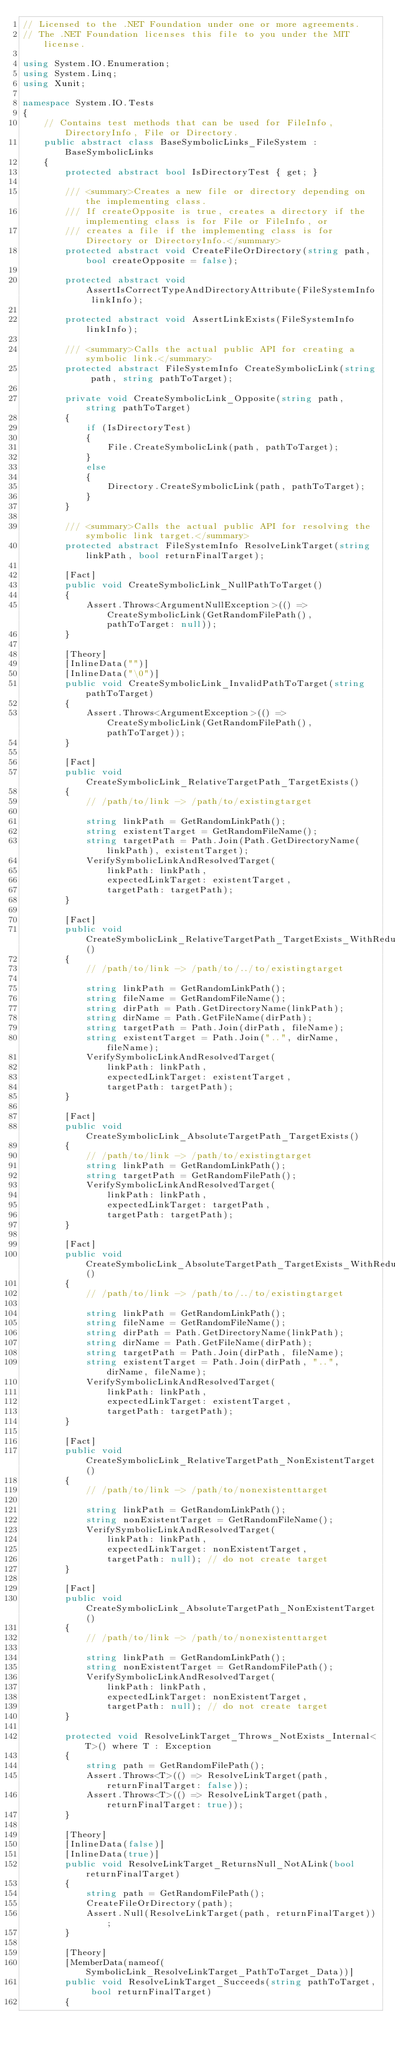Convert code to text. <code><loc_0><loc_0><loc_500><loc_500><_C#_>// Licensed to the .NET Foundation under one or more agreements.
// The .NET Foundation licenses this file to you under the MIT license.

using System.IO.Enumeration;
using System.Linq;
using Xunit;

namespace System.IO.Tests
{
    // Contains test methods that can be used for FileInfo, DirectoryInfo, File or Directory.
    public abstract class BaseSymbolicLinks_FileSystem : BaseSymbolicLinks
    {
        protected abstract bool IsDirectoryTest { get; }

        /// <summary>Creates a new file or directory depending on the implementing class.
        /// If createOpposite is true, creates a directory if the implementing class is for File or FileInfo, or
        /// creates a file if the implementing class is for Directory or DirectoryInfo.</summary>
        protected abstract void CreateFileOrDirectory(string path, bool createOpposite = false);

        protected abstract void AssertIsCorrectTypeAndDirectoryAttribute(FileSystemInfo linkInfo);

        protected abstract void AssertLinkExists(FileSystemInfo linkInfo);

        /// <summary>Calls the actual public API for creating a symbolic link.</summary>
        protected abstract FileSystemInfo CreateSymbolicLink(string path, string pathToTarget);

        private void CreateSymbolicLink_Opposite(string path, string pathToTarget)
        {
            if (IsDirectoryTest)
            {
                File.CreateSymbolicLink(path, pathToTarget);
            }
            else
            {
                Directory.CreateSymbolicLink(path, pathToTarget);
            }
        }

        /// <summary>Calls the actual public API for resolving the symbolic link target.</summary>
        protected abstract FileSystemInfo ResolveLinkTarget(string linkPath, bool returnFinalTarget);

        [Fact]
        public void CreateSymbolicLink_NullPathToTarget()
        {
            Assert.Throws<ArgumentNullException>(() => CreateSymbolicLink(GetRandomFilePath(), pathToTarget: null));
        }

        [Theory]
        [InlineData("")]
        [InlineData("\0")]
        public void CreateSymbolicLink_InvalidPathToTarget(string pathToTarget)
        {
            Assert.Throws<ArgumentException>(() => CreateSymbolicLink(GetRandomFilePath(), pathToTarget));
        }

        [Fact]
        public void CreateSymbolicLink_RelativeTargetPath_TargetExists()
        {
            // /path/to/link -> /path/to/existingtarget

            string linkPath = GetRandomLinkPath();
            string existentTarget = GetRandomFileName();
            string targetPath = Path.Join(Path.GetDirectoryName(linkPath), existentTarget);
            VerifySymbolicLinkAndResolvedTarget(
                linkPath: linkPath,
                expectedLinkTarget: existentTarget,
                targetPath: targetPath);
        }

        [Fact]
        public void CreateSymbolicLink_RelativeTargetPath_TargetExists_WithRedundantSegments()
        {
            // /path/to/link -> /path/to/../to/existingtarget

            string linkPath = GetRandomLinkPath();
            string fileName = GetRandomFileName();
            string dirPath = Path.GetDirectoryName(linkPath);
            string dirName = Path.GetFileName(dirPath);
            string targetPath = Path.Join(dirPath, fileName);
            string existentTarget = Path.Join("..", dirName, fileName);
            VerifySymbolicLinkAndResolvedTarget(
                linkPath: linkPath,
                expectedLinkTarget: existentTarget,
                targetPath: targetPath);
        }

        [Fact]
        public void CreateSymbolicLink_AbsoluteTargetPath_TargetExists()
        {
            // /path/to/link -> /path/to/existingtarget
            string linkPath = GetRandomLinkPath();
            string targetPath = GetRandomFilePath();
            VerifySymbolicLinkAndResolvedTarget(
                linkPath: linkPath,
                expectedLinkTarget: targetPath,
                targetPath: targetPath);
        }

        [Fact]
        public void CreateSymbolicLink_AbsoluteTargetPath_TargetExists_WithRedundantSegments()
        {
            // /path/to/link -> /path/to/../to/existingtarget

            string linkPath = GetRandomLinkPath();
            string fileName = GetRandomFileName();
            string dirPath = Path.GetDirectoryName(linkPath);
            string dirName = Path.GetFileName(dirPath);
            string targetPath = Path.Join(dirPath, fileName);
            string existentTarget = Path.Join(dirPath, "..", dirName, fileName);
            VerifySymbolicLinkAndResolvedTarget(
                linkPath: linkPath,
                expectedLinkTarget: existentTarget,
                targetPath: targetPath);
        }

        [Fact]
        public void CreateSymbolicLink_RelativeTargetPath_NonExistentTarget()
        {
            // /path/to/link -> /path/to/nonexistenttarget

            string linkPath = GetRandomLinkPath();
            string nonExistentTarget = GetRandomFileName();
            VerifySymbolicLinkAndResolvedTarget(
                linkPath: linkPath,
                expectedLinkTarget: nonExistentTarget,
                targetPath: null); // do not create target
        }

        [Fact]
        public void CreateSymbolicLink_AbsoluteTargetPath_NonExistentTarget()
        {
            // /path/to/link -> /path/to/nonexistenttarget

            string linkPath = GetRandomLinkPath();
            string nonExistentTarget = GetRandomFilePath();
            VerifySymbolicLinkAndResolvedTarget(
                linkPath: linkPath,
                expectedLinkTarget: nonExistentTarget,
                targetPath: null); // do not create target
        }

        protected void ResolveLinkTarget_Throws_NotExists_Internal<T>() where T : Exception
        {
            string path = GetRandomFilePath();
            Assert.Throws<T>(() => ResolveLinkTarget(path, returnFinalTarget: false));
            Assert.Throws<T>(() => ResolveLinkTarget(path, returnFinalTarget: true));
        }

        [Theory]
        [InlineData(false)]
        [InlineData(true)]
        public void ResolveLinkTarget_ReturnsNull_NotALink(bool returnFinalTarget)
        {
            string path = GetRandomFilePath();
            CreateFileOrDirectory(path);
            Assert.Null(ResolveLinkTarget(path, returnFinalTarget));
        }

        [Theory]
        [MemberData(nameof(SymbolicLink_ResolveLinkTarget_PathToTarget_Data))]
        public void ResolveLinkTarget_Succeeds(string pathToTarget, bool returnFinalTarget)
        {</code> 